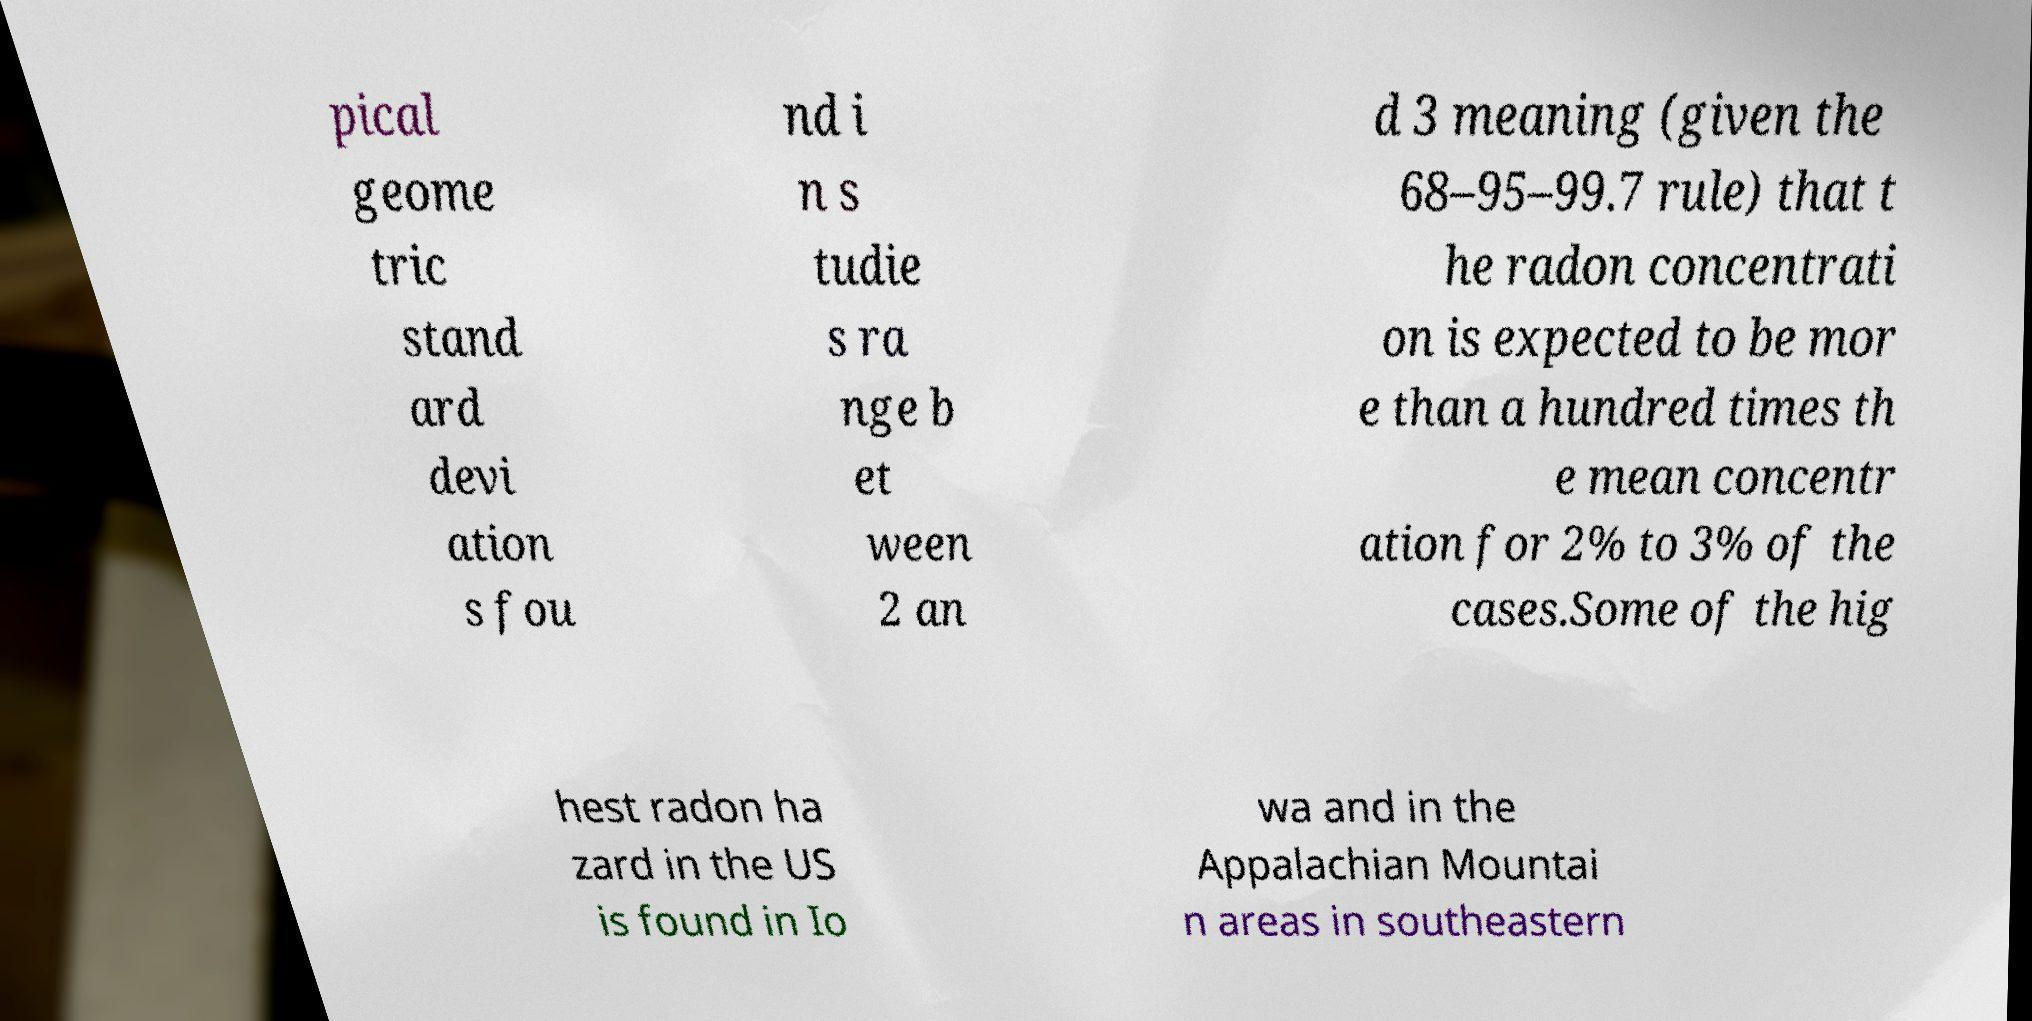Can you accurately transcribe the text from the provided image for me? pical geome tric stand ard devi ation s fou nd i n s tudie s ra nge b et ween 2 an d 3 meaning (given the 68–95–99.7 rule) that t he radon concentrati on is expected to be mor e than a hundred times th e mean concentr ation for 2% to 3% of the cases.Some of the hig hest radon ha zard in the US is found in Io wa and in the Appalachian Mountai n areas in southeastern 